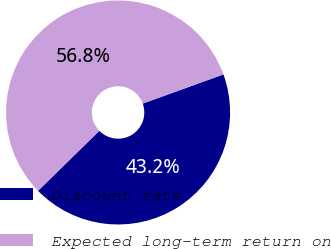<chart> <loc_0><loc_0><loc_500><loc_500><pie_chart><fcel>Discount rate<fcel>Expected long-term return on<nl><fcel>43.19%<fcel>56.81%<nl></chart> 